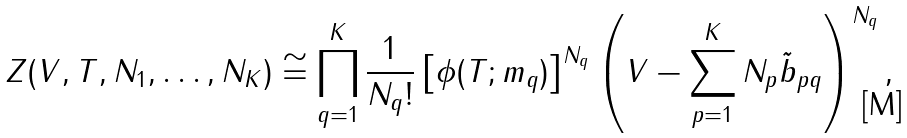<formula> <loc_0><loc_0><loc_500><loc_500>Z ( V , T , N _ { 1 } , \dots , N _ { K } ) \cong \prod _ { q = 1 } ^ { K } \frac { 1 } { N _ { q } ! } \left [ \phi ( T ; m _ { q } ) \right ] ^ { N _ { q } } \left ( V - \sum _ { p = 1 } ^ { K } N _ { p } \tilde { b } _ { p q } \right ) ^ { N _ { q } } ,</formula> 